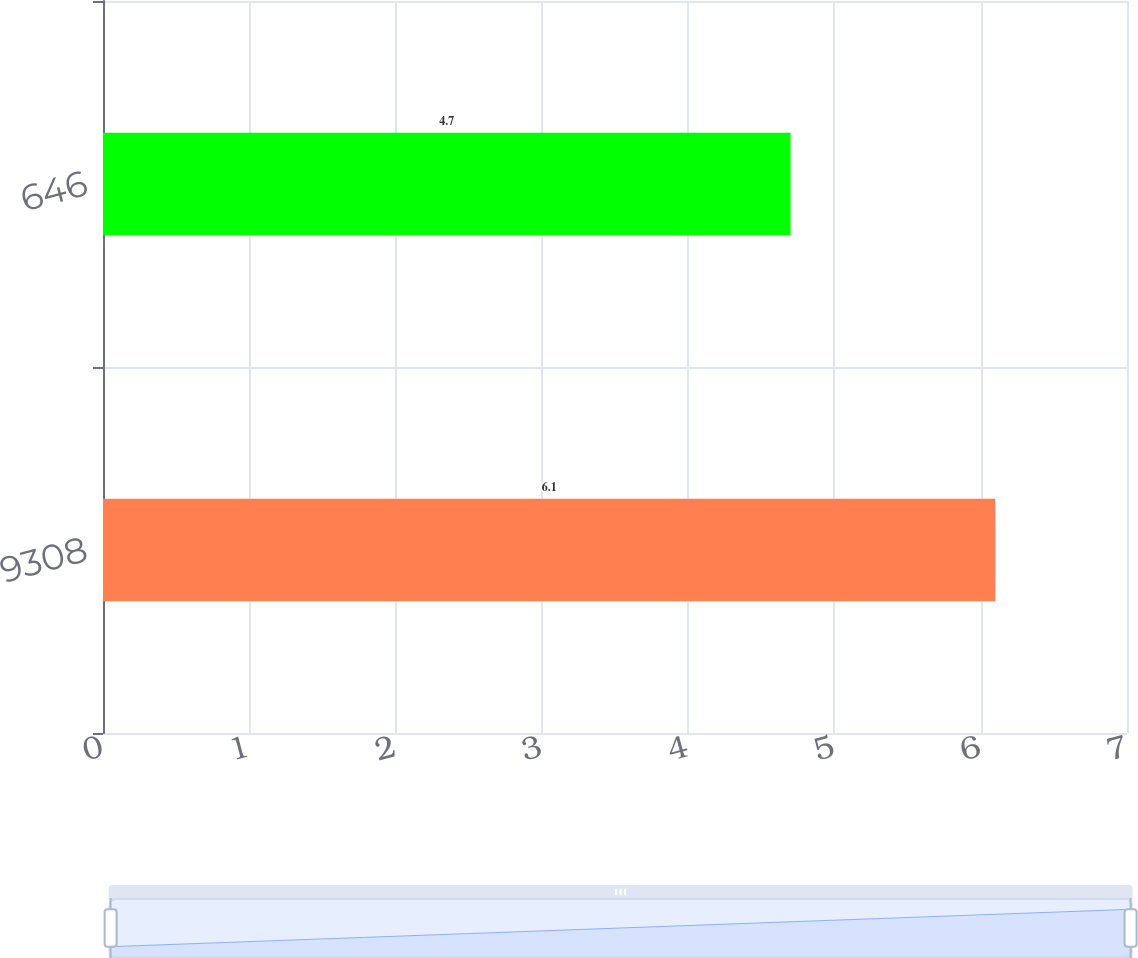Convert chart. <chart><loc_0><loc_0><loc_500><loc_500><bar_chart><fcel>9308<fcel>646<nl><fcel>6.1<fcel>4.7<nl></chart> 